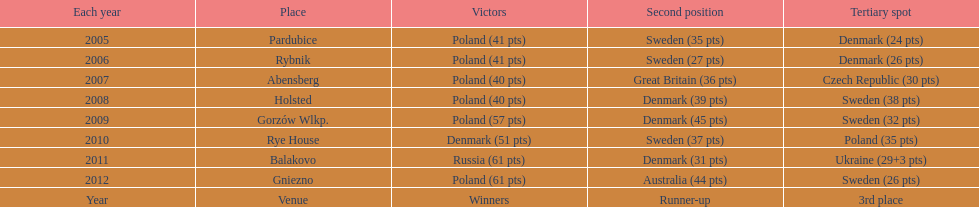What was the difference in final score between russia and denmark in 2011? 30. 